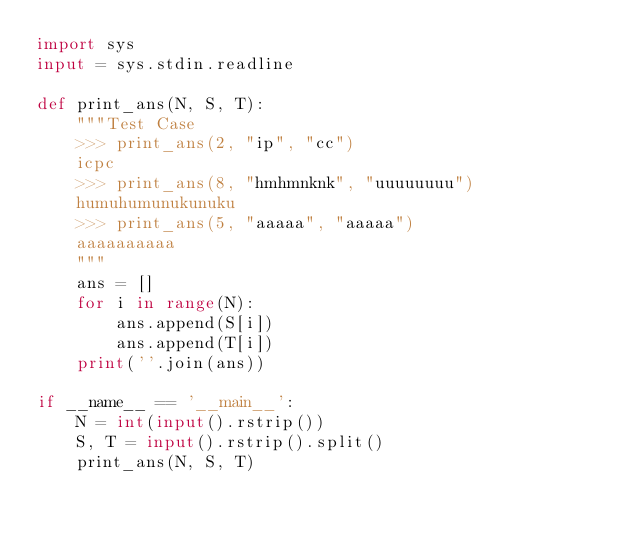Convert code to text. <code><loc_0><loc_0><loc_500><loc_500><_Python_>import sys
input = sys.stdin.readline

def print_ans(N, S, T):
    """Test Case
    >>> print_ans(2, "ip", "cc")
    icpc
    >>> print_ans(8, "hmhmnknk", "uuuuuuuu")
    humuhumunukunuku
    >>> print_ans(5, "aaaaa", "aaaaa")
    aaaaaaaaaa
    """
    ans = []
    for i in range(N):
        ans.append(S[i])
        ans.append(T[i])
    print(''.join(ans))

if __name__ == '__main__':
    N = int(input().rstrip())
    S, T = input().rstrip().split()
    print_ans(N, S, T)


</code> 